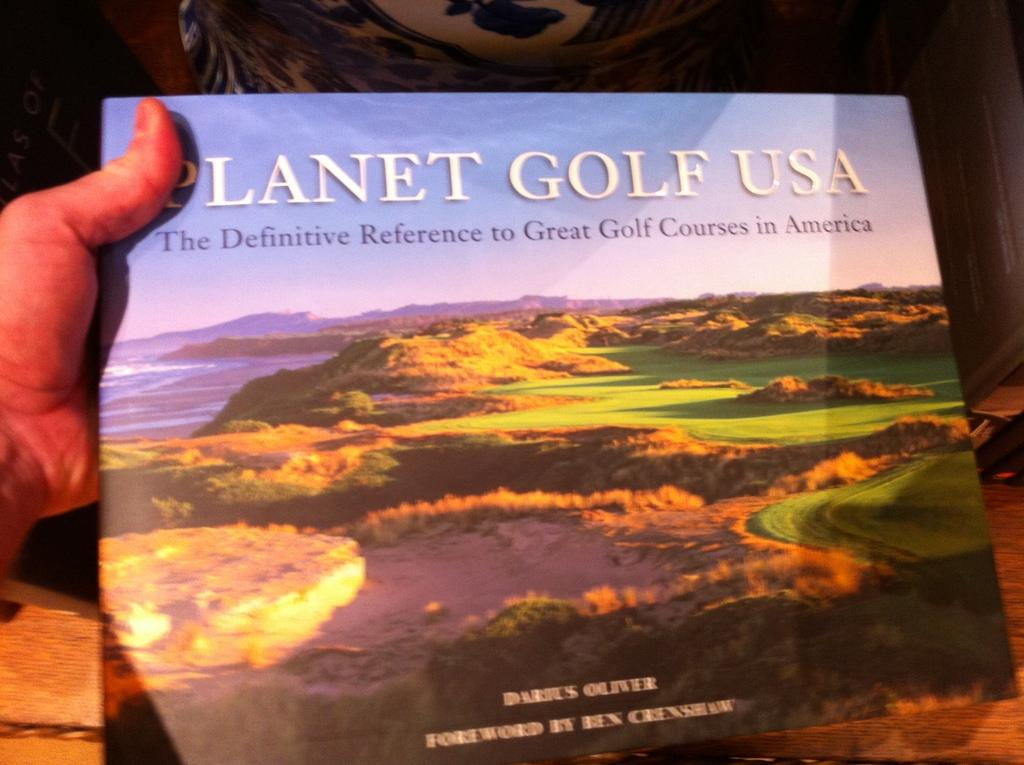<image>
Offer a succinct explanation of the picture presented. a book about golf called planer gold usa 